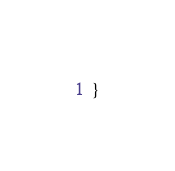Convert code to text. <code><loc_0><loc_0><loc_500><loc_500><_Python_>}
</code> 